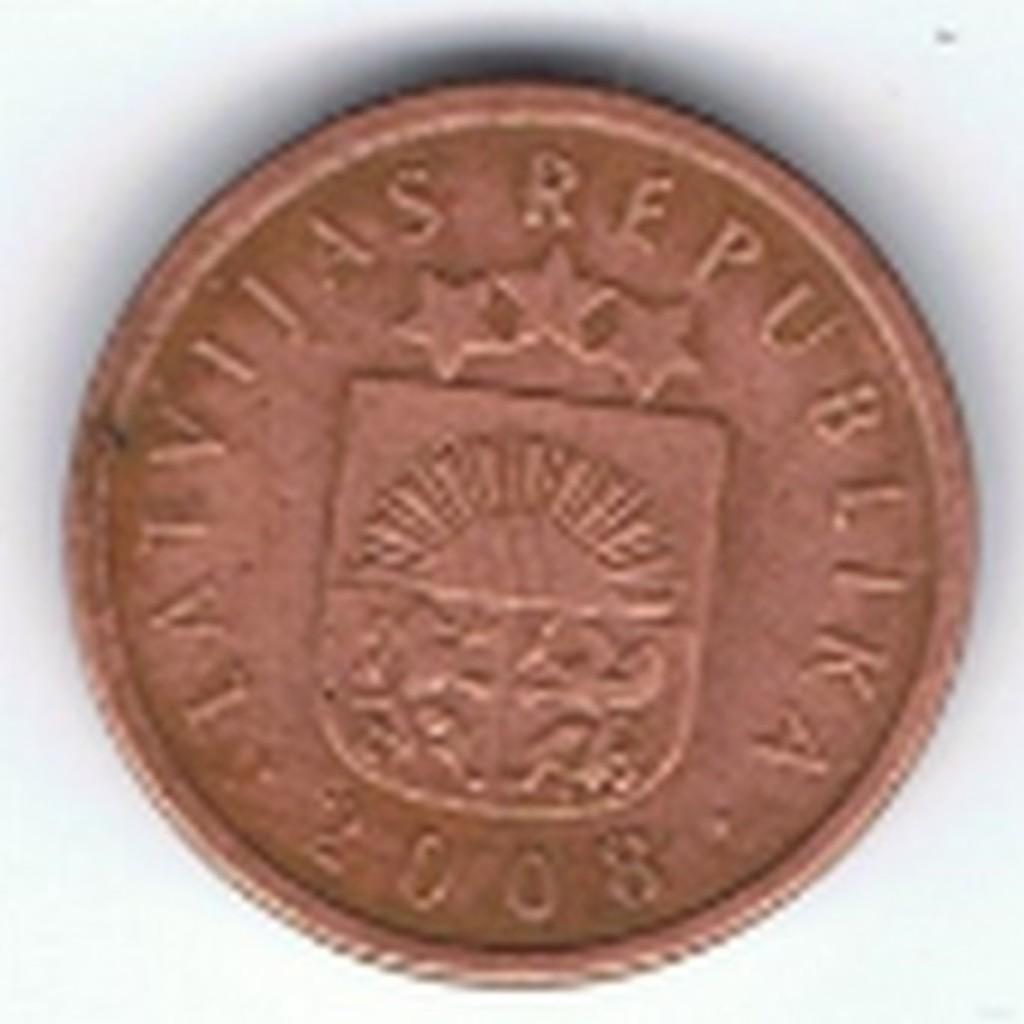<image>
Describe the image concisely. Copper coin showing three stars from the year 2008. 